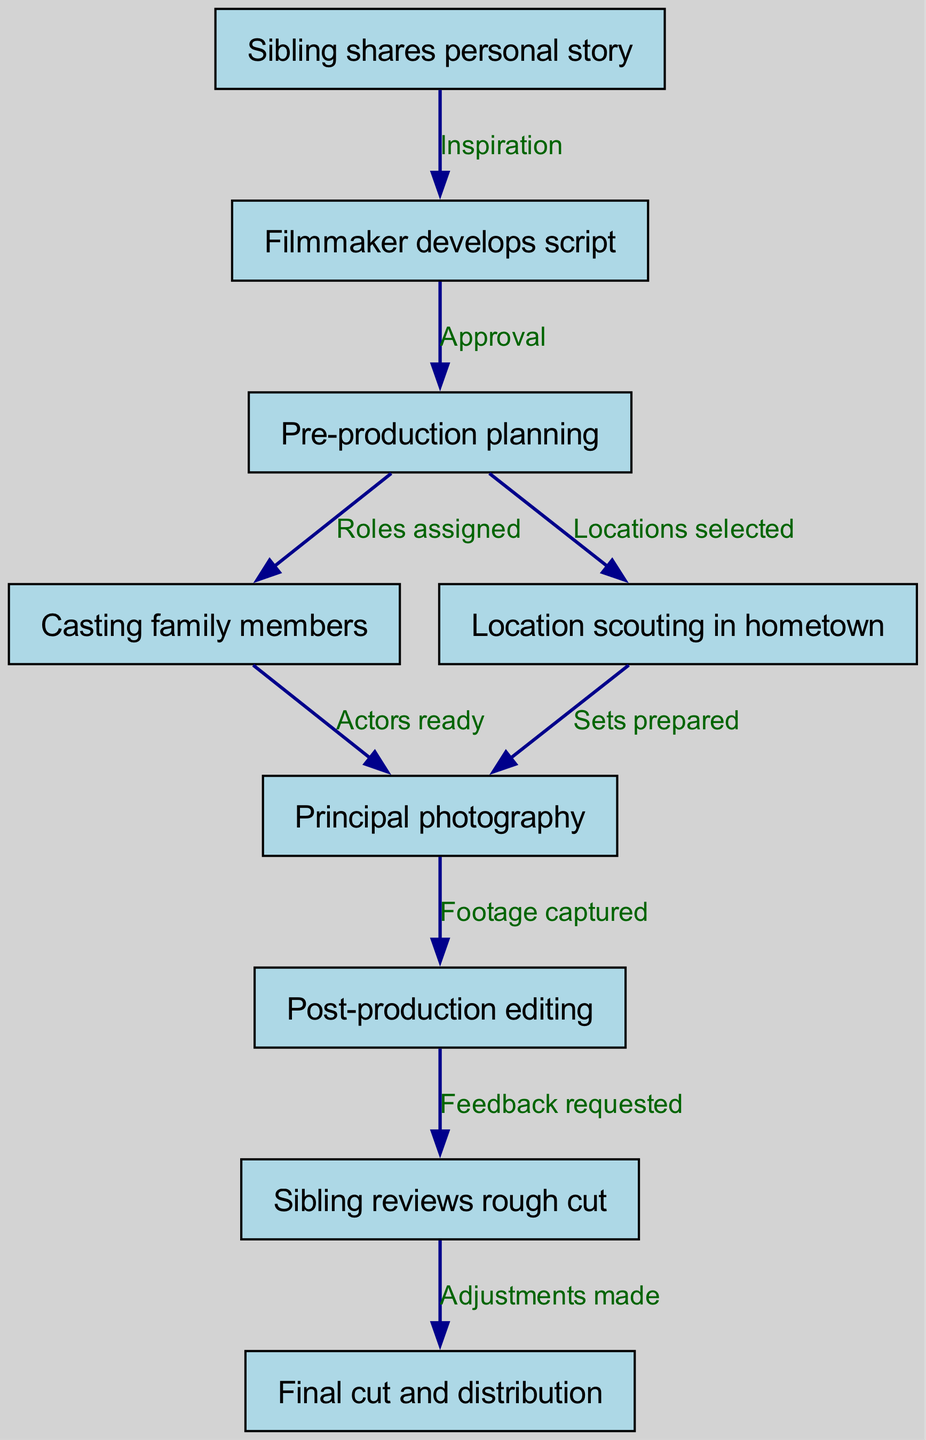What is the first step in the filmmaking process? The first step is labeled as "Sibling shares personal story," which initiates the flow of the diagram.
Answer: Sibling shares personal story How many nodes are present in the diagram? Counting all the nodes listed, there are a total of nine distinct steps in the filmmaking process depicted.
Answer: Nine What action follows the "Pre-production planning"? The action that directly follows is "Casting family members," indicating that once planning is done, casting occurs next in the process.
Answer: Casting family members What is the relationship between "Post-production editing" and "Sibling reviews rough cut"? The edge connects "Post-production editing" to "Sibling reviews rough cut" with the label "Feedback requested," indicating that this step requests feedback on the editing done.
Answer: Feedback requested Which two steps involve preparing something? "Casting family members" involves preparing actors, and "Location scouting in hometown" involves preparing locations for filming, both requiring preparations for the next steps.
Answer: Casting family members and Location scouting in hometown What is the final step of the filmmaking process? The final step labeled in the flowchart is "Final cut and distribution," which signifies the completion and sharing of the film.
Answer: Final cut and distribution What needs to be completed before the "Principal photography" can start? Both "Casting family members" and "Location scouting in hometown" must be completed, as actors need to be ready and locations prepared for the principal photography step to commence.
Answer: Casting family members and Location scouting in hometown How does the "Sibling reviews rough cut" influence the final outcome? This step labeled "Adjustments made" shows that the feedback from the sibling during the review directly leads to the final cut before distribution, ensuring that their input shapes the end product.
Answer: Adjustments made What is the edge label between "Pre-production planning" and "Principal photography"? The edge label between these two nodes is "Roles assigned," indicating that role assignments are a necessary precursor to shooting the film.
Answer: Roles assigned 